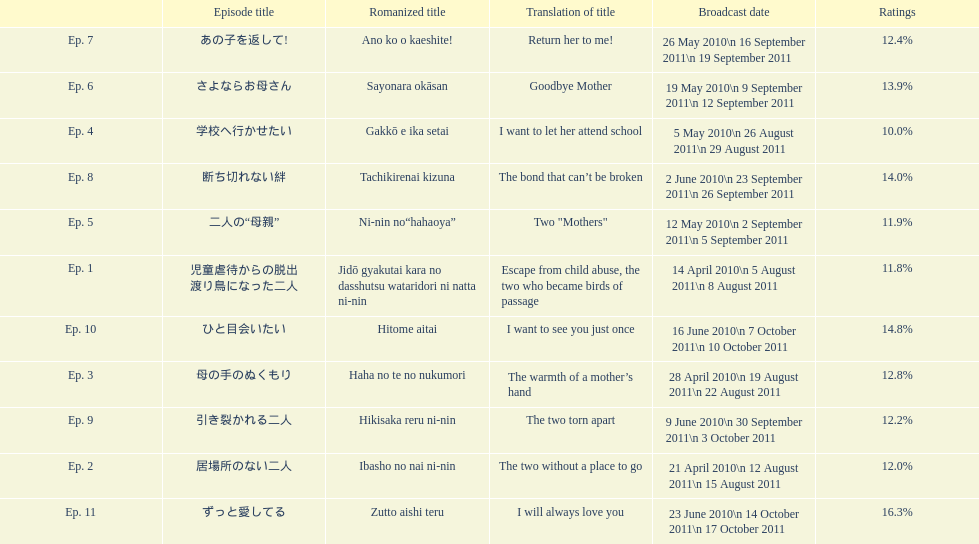How many episodes are listed? 11. 